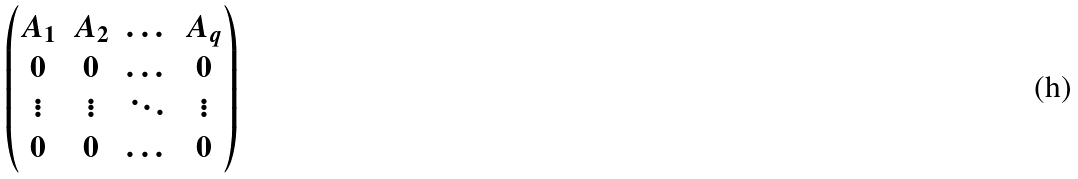<formula> <loc_0><loc_0><loc_500><loc_500>\begin{pmatrix} A _ { 1 } & A _ { 2 } & \dots & A _ { q } \\ 0 & 0 & \dots & 0 \\ \vdots & \vdots & \ddots & \vdots \\ 0 & 0 & \dots & 0 \\ \end{pmatrix}</formula> 